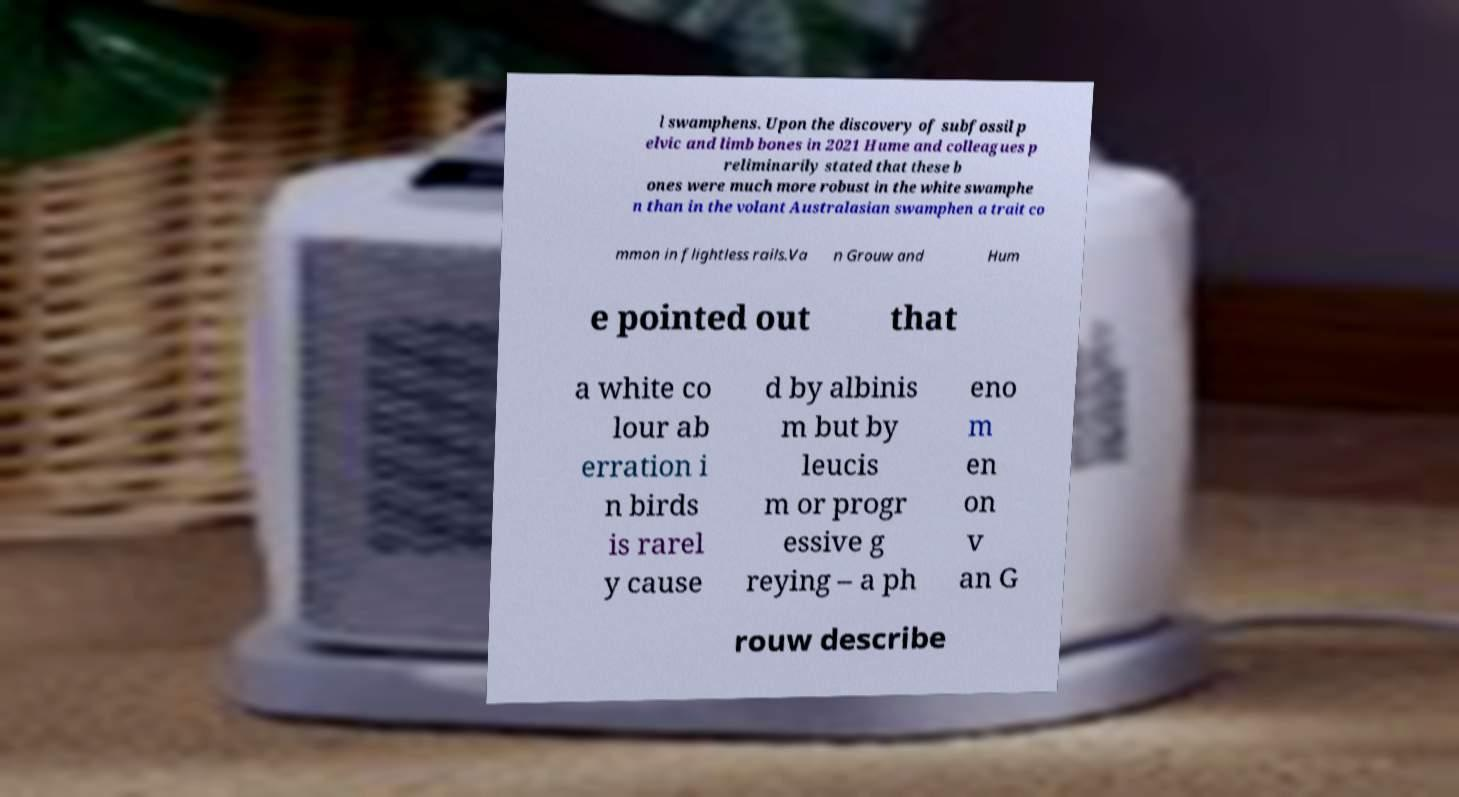Could you assist in decoding the text presented in this image and type it out clearly? l swamphens. Upon the discovery of subfossil p elvic and limb bones in 2021 Hume and colleagues p reliminarily stated that these b ones were much more robust in the white swamphe n than in the volant Australasian swamphen a trait co mmon in flightless rails.Va n Grouw and Hum e pointed out that a white co lour ab erration i n birds is rarel y cause d by albinis m but by leucis m or progr essive g reying – a ph eno m en on v an G rouw describe 